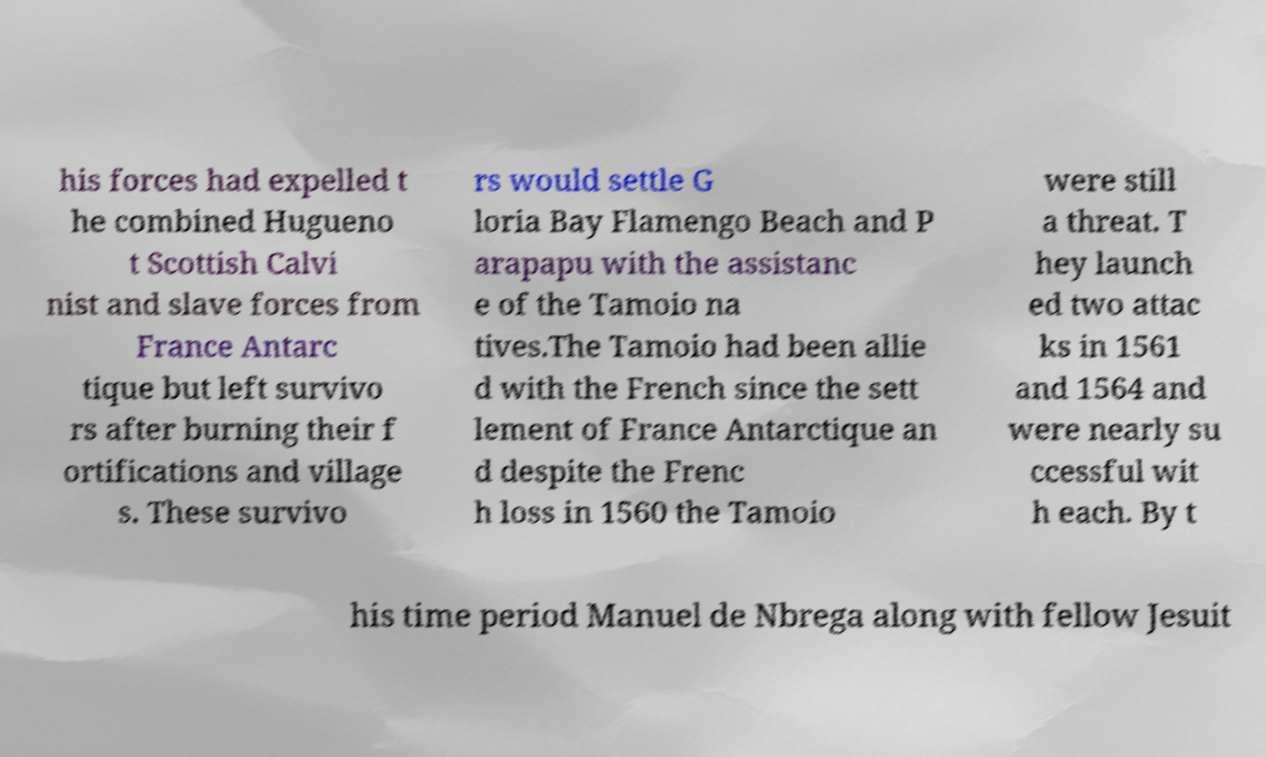Please identify and transcribe the text found in this image. his forces had expelled t he combined Hugueno t Scottish Calvi nist and slave forces from France Antarc tique but left survivo rs after burning their f ortifications and village s. These survivo rs would settle G loria Bay Flamengo Beach and P arapapu with the assistanc e of the Tamoio na tives.The Tamoio had been allie d with the French since the sett lement of France Antarctique an d despite the Frenc h loss in 1560 the Tamoio were still a threat. T hey launch ed two attac ks in 1561 and 1564 and were nearly su ccessful wit h each. By t his time period Manuel de Nbrega along with fellow Jesuit 